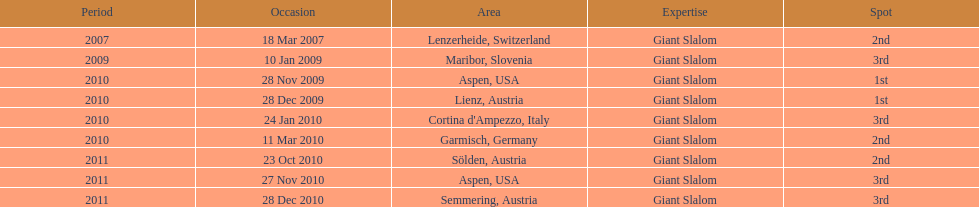How many races were in 2010? 5. 